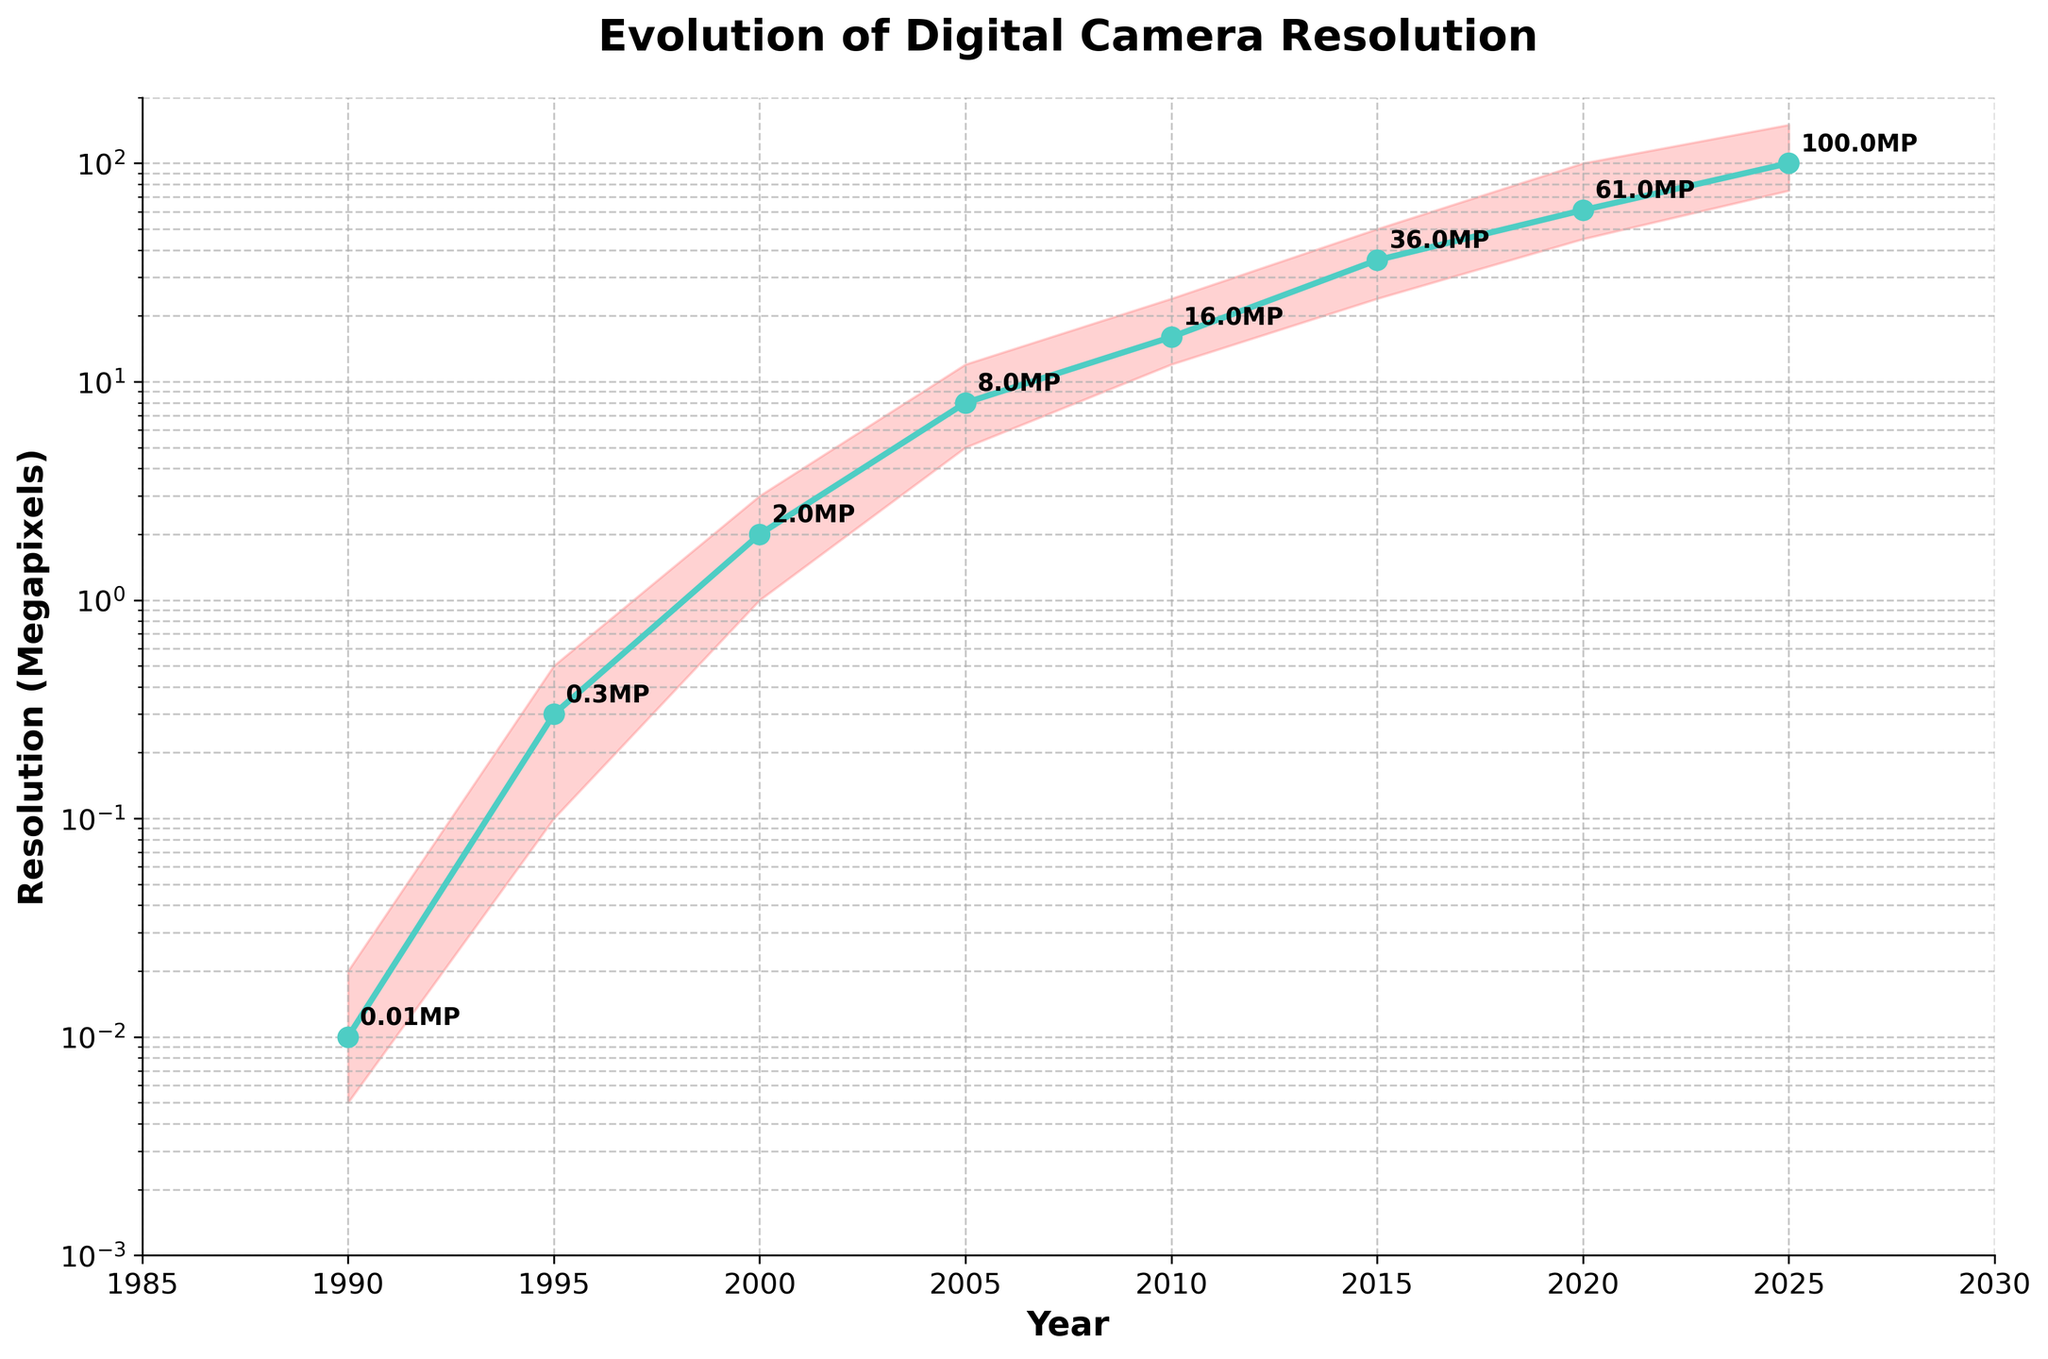When did digital cameras first reach a resolution of around 1 megapixel? The figure shows the progression of image resolution over the years. Around 1995, the resolution reaches approximately 0.3 megapixels. By the year 2000, the resolution is seen to be around 2 megapixels, so the closest year to achieving around 1 megapixel would fall between 1995 and 2000.
Answer: 2000 What is the highest resolution recorded in the year 2025? To find the highest resolution, refer to the "High" value for the year 2025 in the fan chart. According to the data, the highest resolution recorded in 2025 is 150 megapixels.
Answer: 150 MP How does the resolution in 2010 compare to that in 2005? Look at the "Medium" values for the years 2005 and 2010. The medium resolution in 2005 is 8 megapixels, and in 2010 it is 16 megapixels. This means the resolution doubled from 2005 to 2010.
Answer: Doubled How many years did it take for the medium resolution to go from 8 megapixels to 100 megapixels? Observe the medium resolution values over the years on the chart. The medium resolution reached 8 megapixels in 2005 and 100 megapixels in 2025. The number of years it took is 2025 - 2005 = 20 years.
Answer: 20 years In which year did the median resolution reach 36 megapixels? Locate the value of 36 megapixels in the "Medium" category on the chart. The figure shows that this occurred in the year 2015.
Answer: 2015 How much did the high-resolution value increase from 2000 to 2020? Check the "High" values for 2000 and 2020 on the chart. In 2000, the high resolution was 3 megapixels, and in 2020 it was 100 megapixels. The increase is 100 - 3 = 97 megapixels.
Answer: 97 MP What's the approximate range of resolutions (difference between highest and lowest) in 2015? Examine the high and low-resolution values for the year 2015. The high resolution is 50 megapixels, and the low resolution is 24 megapixels. The range is 50 - 24 = 26 megapixels.
Answer: 26 MP How did the medium resolution value change from 1995 to 2000? Look at the medium resolution values for the years 1995 and 2000. The medium resolution was 0.3 megapixels in 1995 and increased to 2 megapixels in 2000.
Answer: Increased by 1.7 MP What is the general trend of digital camera resolutions over the years shown in the chart? The trend line showing median resolution and the filled area between low and high resolutions all indicate an overall increasing trend in digital camera resolutions from 1990 to 2025.
Answer: Increasing 